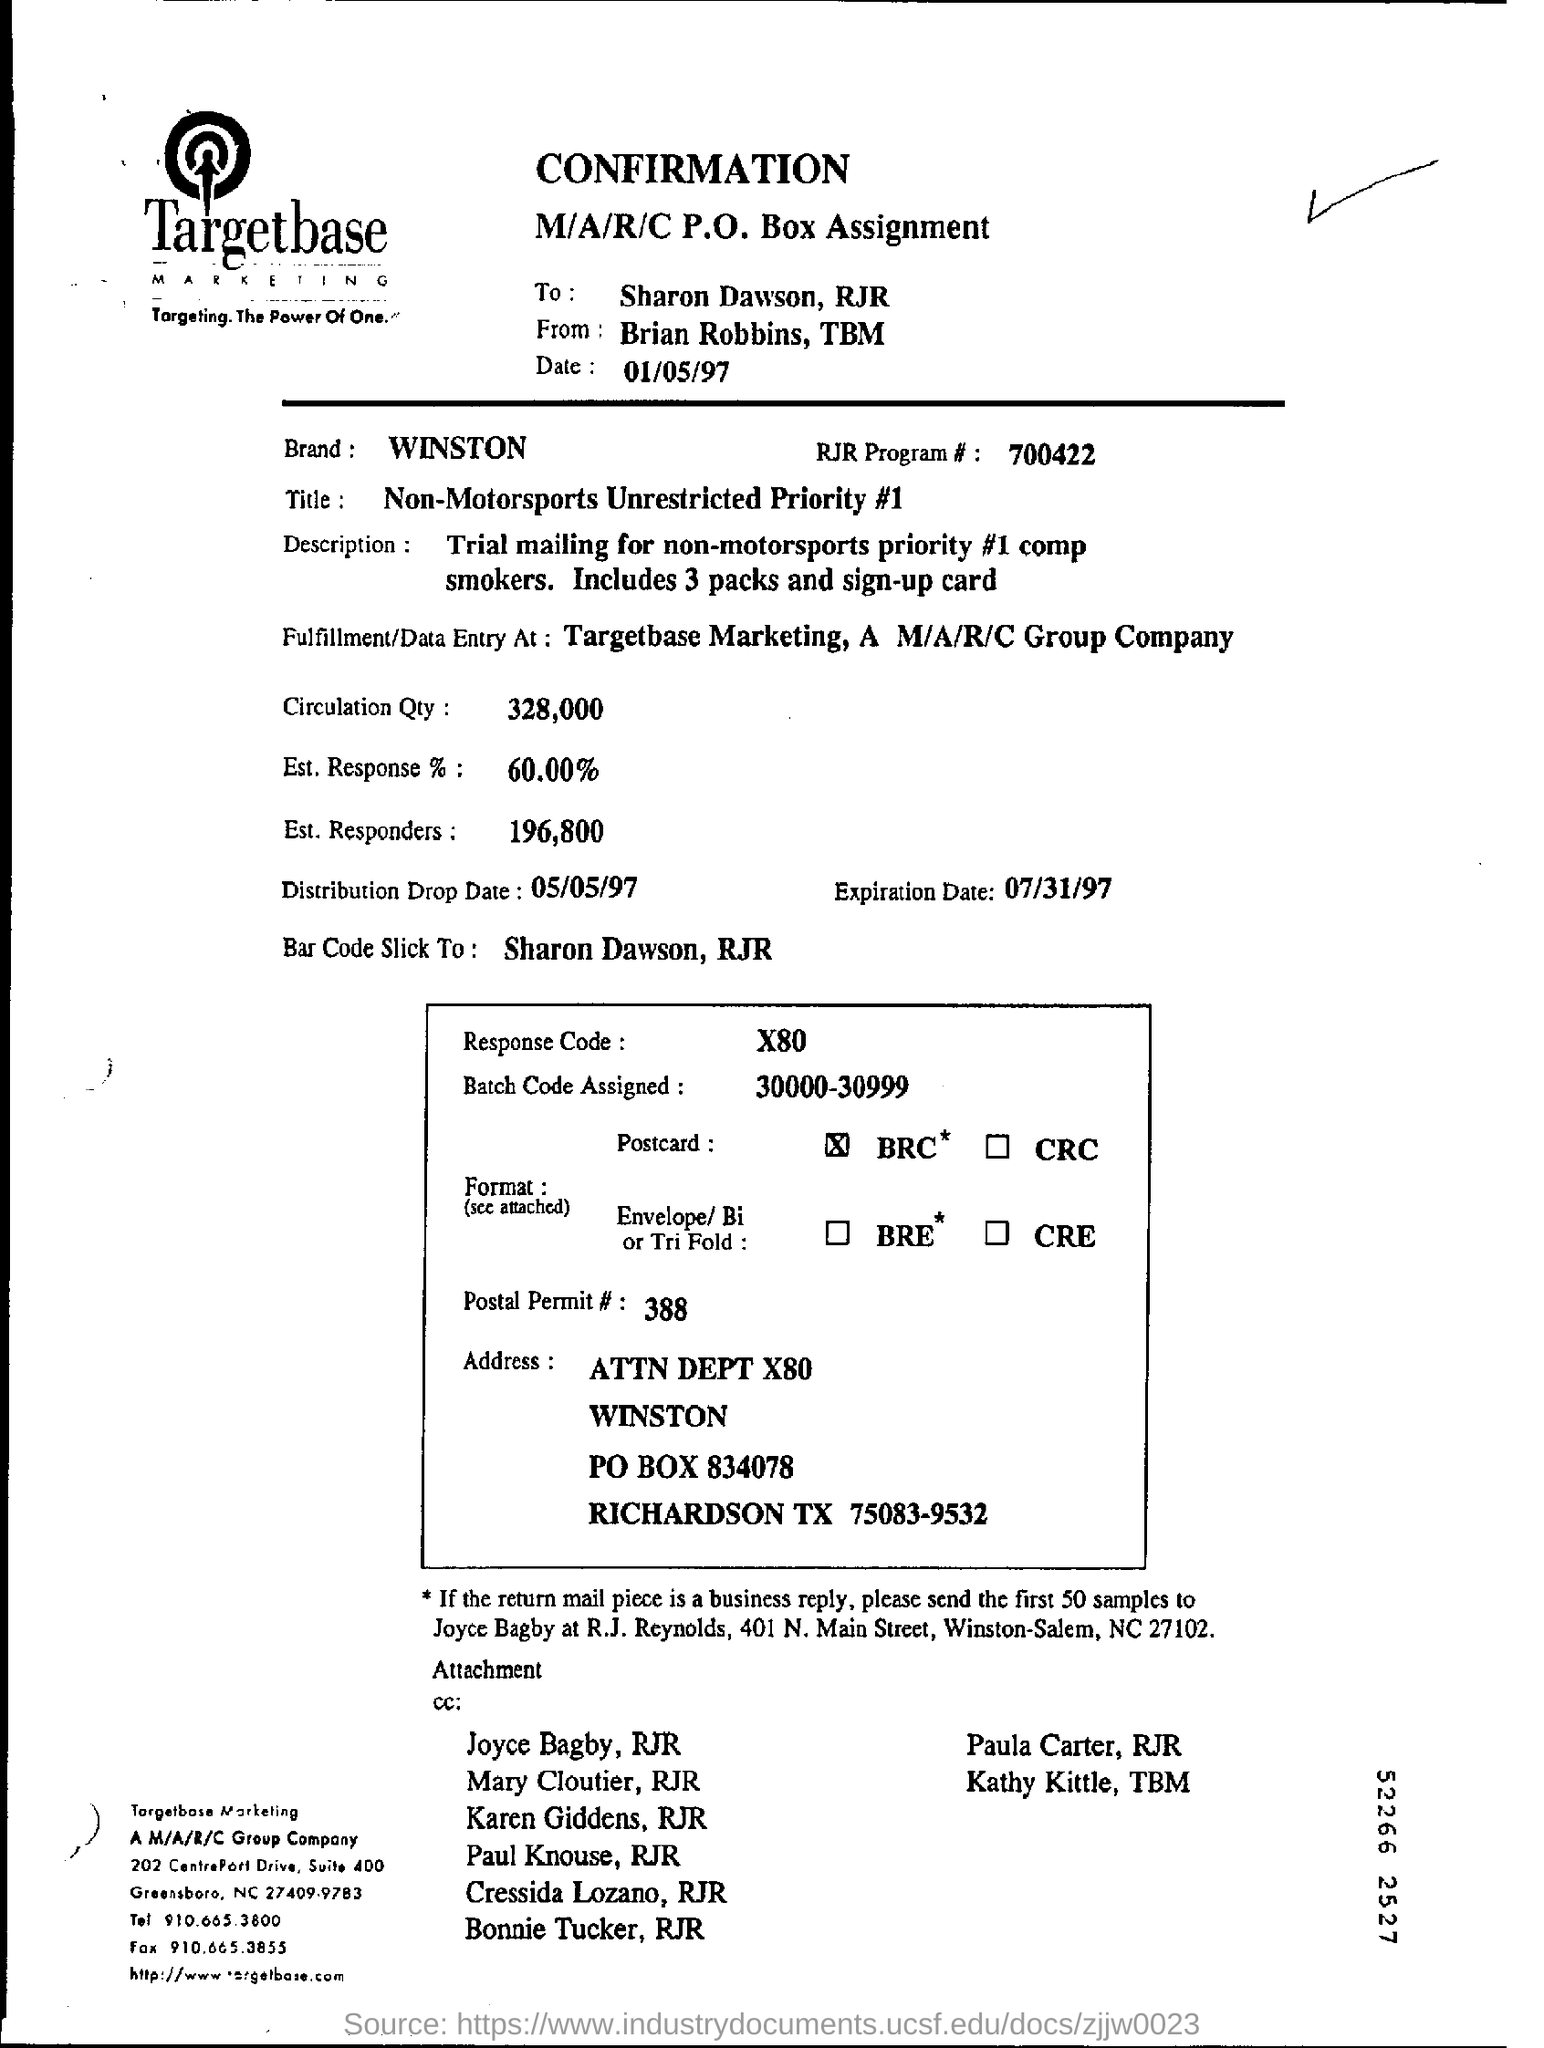Give some essential details in this illustration. The expiration date is July 31st, 1997. The Est response is 60.00%. 